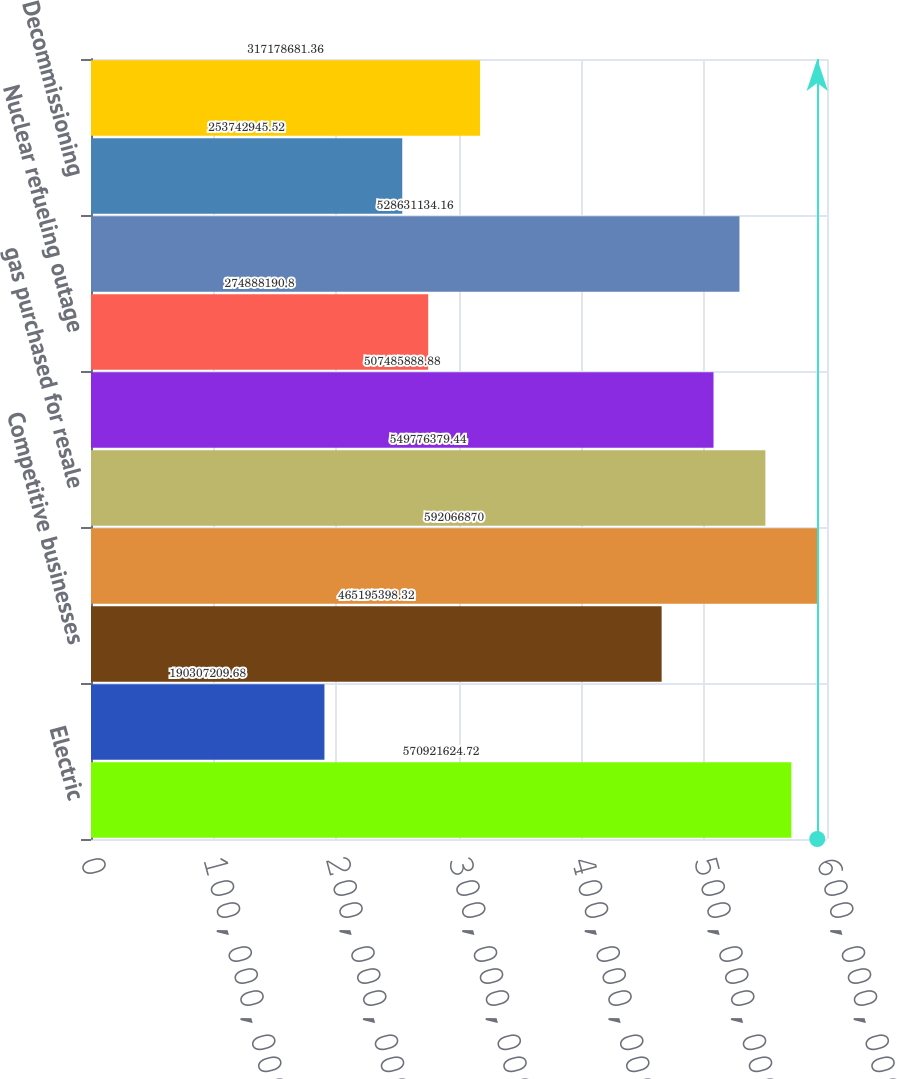<chart> <loc_0><loc_0><loc_500><loc_500><bar_chart><fcel>Electric<fcel>Natural gas<fcel>Competitive businesses<fcel>TOTAL<fcel>gas purchased for resale<fcel>Purchased power<fcel>Nuclear refueling outage<fcel>Other operation and<fcel>Decommissioning<fcel>Taxes other than income taxes<nl><fcel>5.70922e+08<fcel>1.90307e+08<fcel>4.65195e+08<fcel>5.92067e+08<fcel>5.49776e+08<fcel>5.07486e+08<fcel>2.74888e+08<fcel>5.28631e+08<fcel>2.53743e+08<fcel>3.17179e+08<nl></chart> 